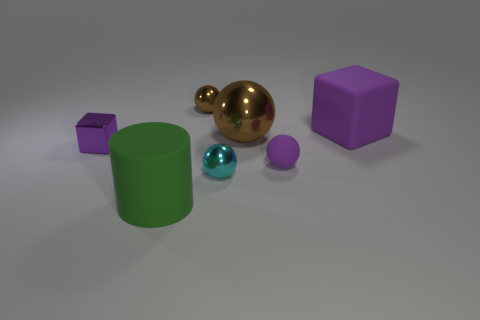Subtract all purple cubes. How many were subtracted if there are1purple cubes left? 1 Subtract all cyan metallic spheres. How many spheres are left? 3 Add 5 small spheres. How many small spheres are left? 8 Add 6 tiny purple cubes. How many tiny purple cubes exist? 7 Add 1 big brown metal cylinders. How many objects exist? 8 Subtract all purple balls. How many balls are left? 3 Subtract 0 red cylinders. How many objects are left? 7 Subtract all cubes. How many objects are left? 5 Subtract 2 balls. How many balls are left? 2 Subtract all purple cylinders. Subtract all cyan blocks. How many cylinders are left? 1 